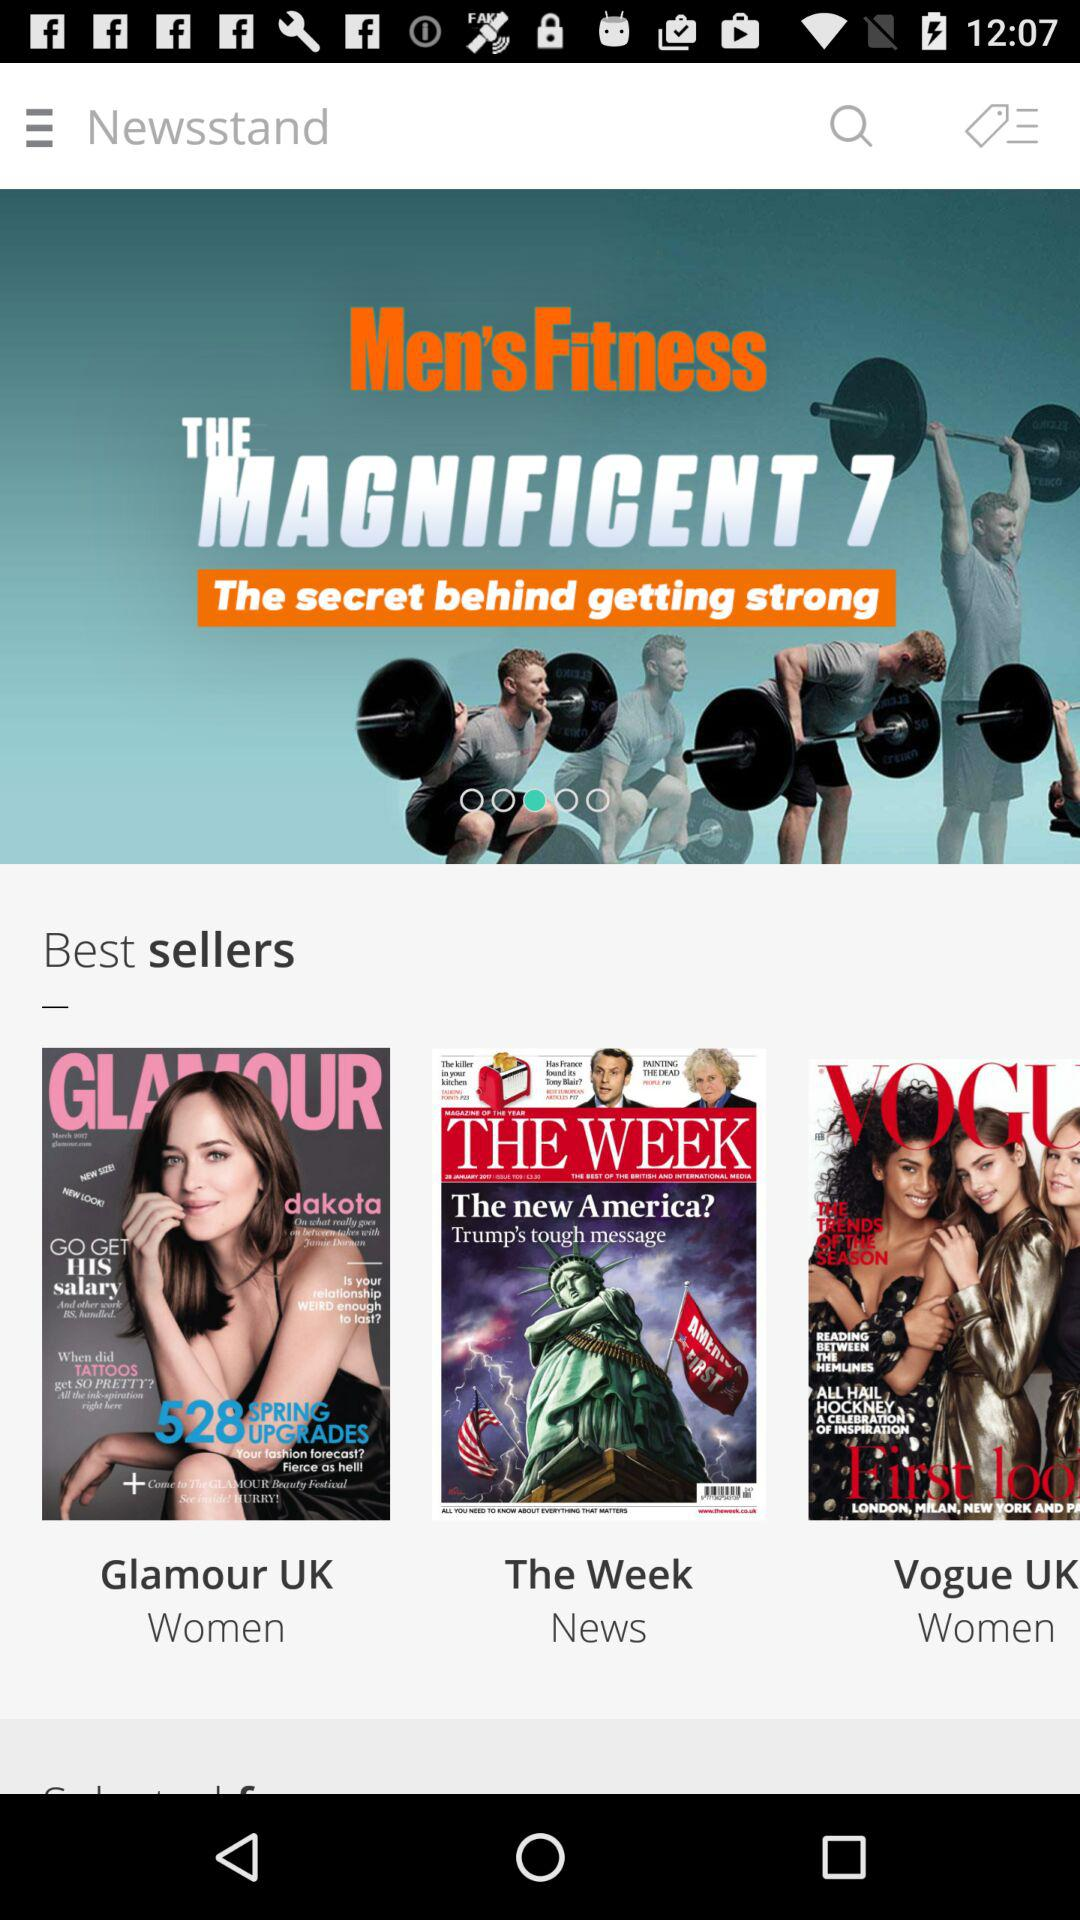What are the best selling magazines for women? The magazines are "Glamour UK" and "Vogue UK". 